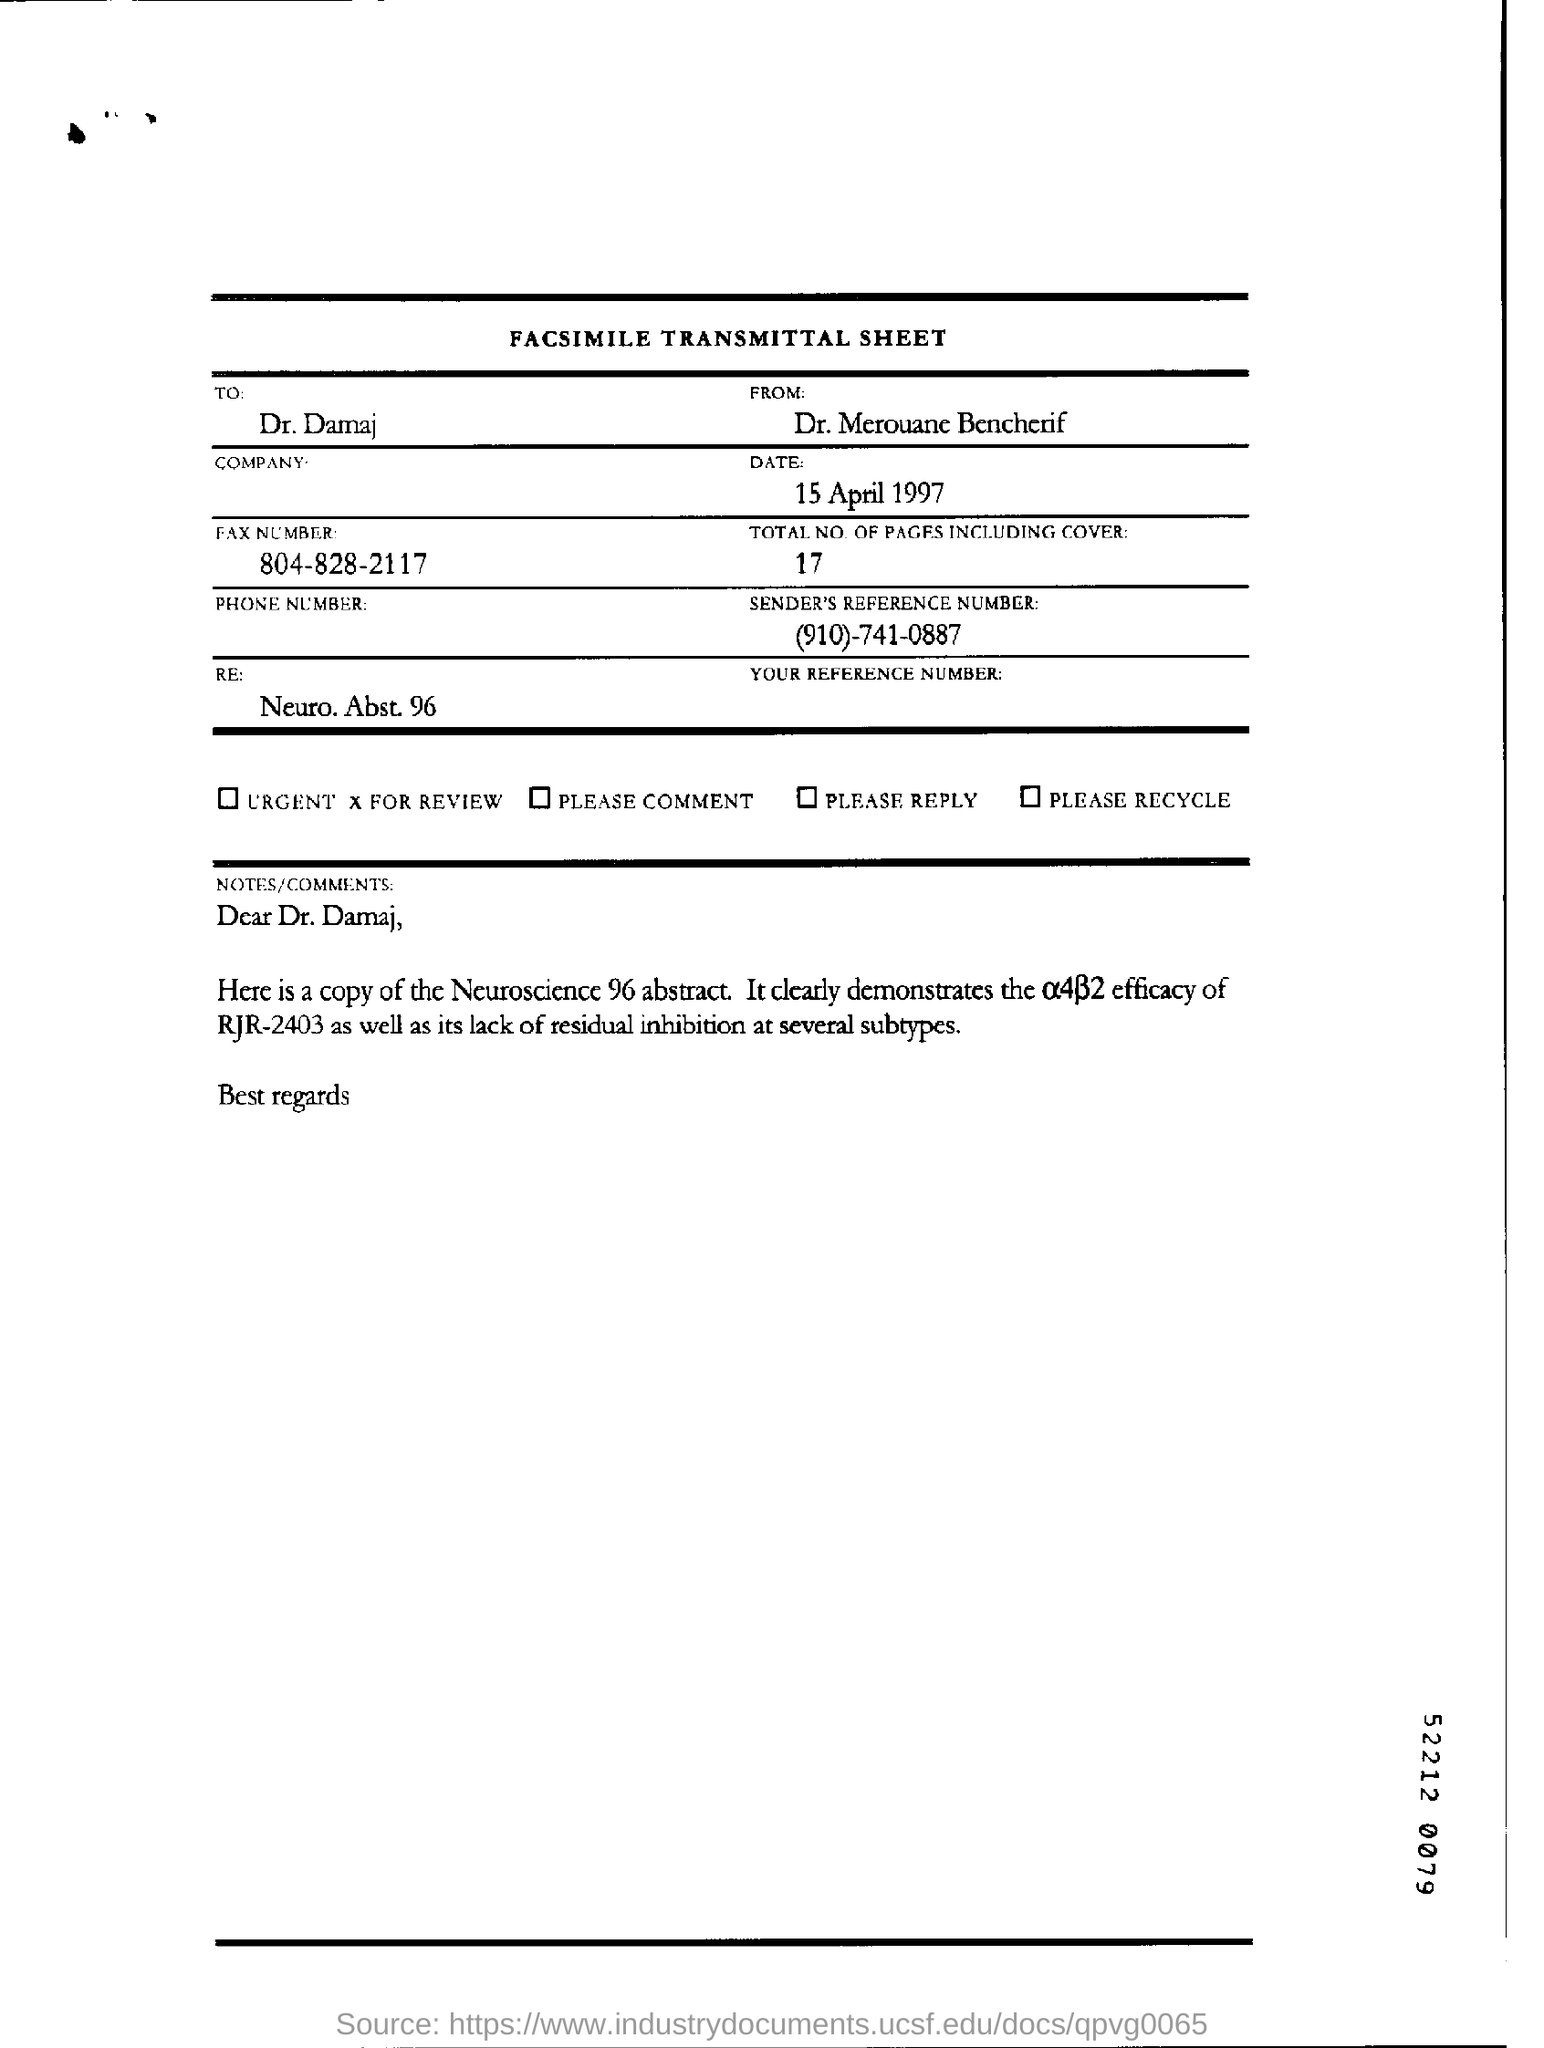List a handful of essential elements in this visual. The total number of pages is 17. The document was created on April 15, 1997. 